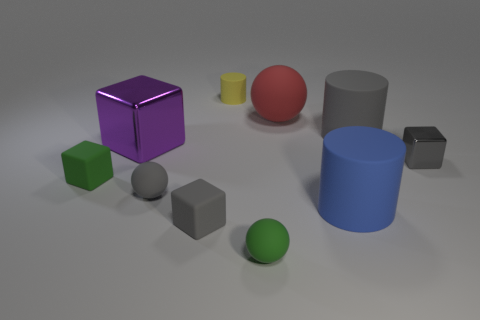Do the tiny thing that is to the right of the large rubber ball and the purple thing have the same shape?
Ensure brevity in your answer.  Yes. What number of objects are either purple blocks or small cylinders that are behind the red object?
Offer a very short reply. 2. Is the number of yellow things that are to the right of the yellow object greater than the number of tiny metallic things?
Your answer should be compact. No. Are there an equal number of gray cylinders behind the tiny yellow thing and large matte spheres that are left of the big red matte object?
Offer a very short reply. Yes. Is there a tiny gray thing on the left side of the gray object that is to the right of the large gray cylinder?
Your response must be concise. Yes. What shape is the large gray rubber thing?
Provide a short and direct response. Cylinder. There is a sphere that is the same color as the small shiny cube; what size is it?
Make the answer very short. Small. What is the size of the block in front of the green rubber object that is left of the tiny yellow rubber cylinder?
Offer a very short reply. Small. How big is the shiny object that is on the right side of the large shiny cube?
Give a very brief answer. Small. Are there fewer small gray blocks that are in front of the gray metallic object than blue things behind the red matte object?
Make the answer very short. No. 